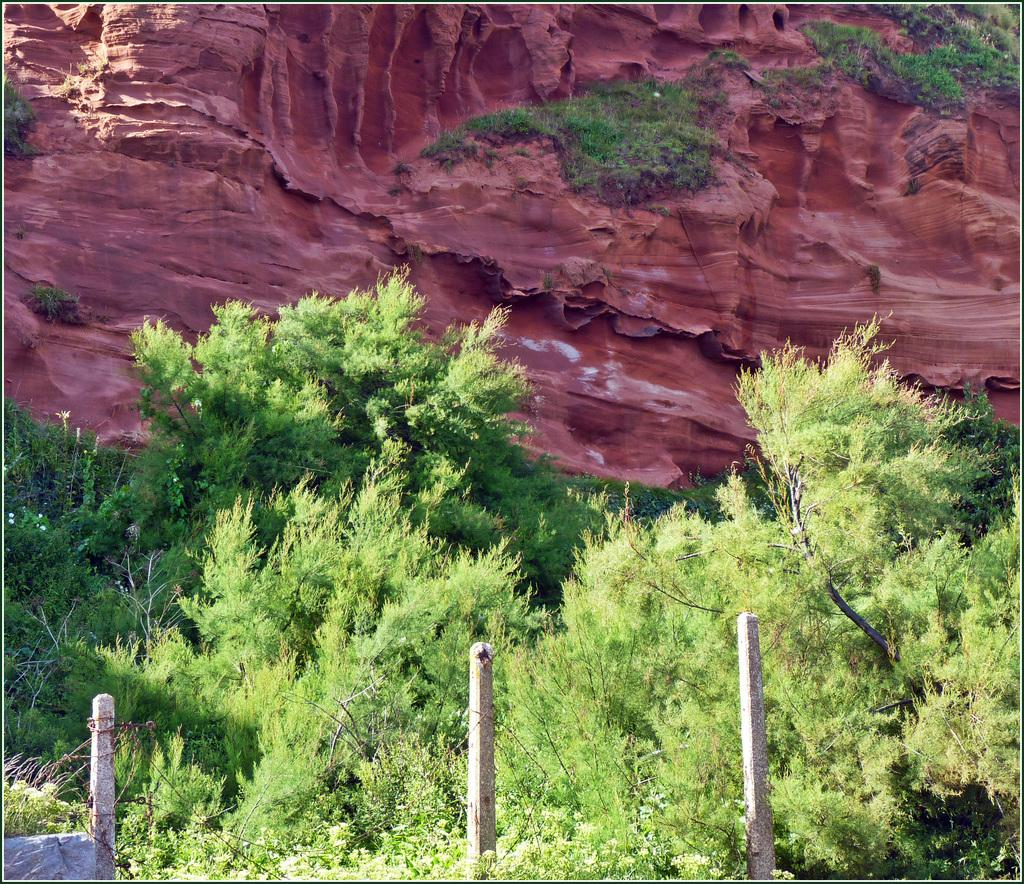Where was the image taken? The image was taken outside. What can be seen in the foreground of the image? There are poles and plants in the foreground of the image. What is visible in the background of the image? There is a rock and a small portion of green grass in the background of the image. Is there a surprise hidden behind the rock in the image? There is no indication of a surprise or any hidden object behind the rock in the image. 